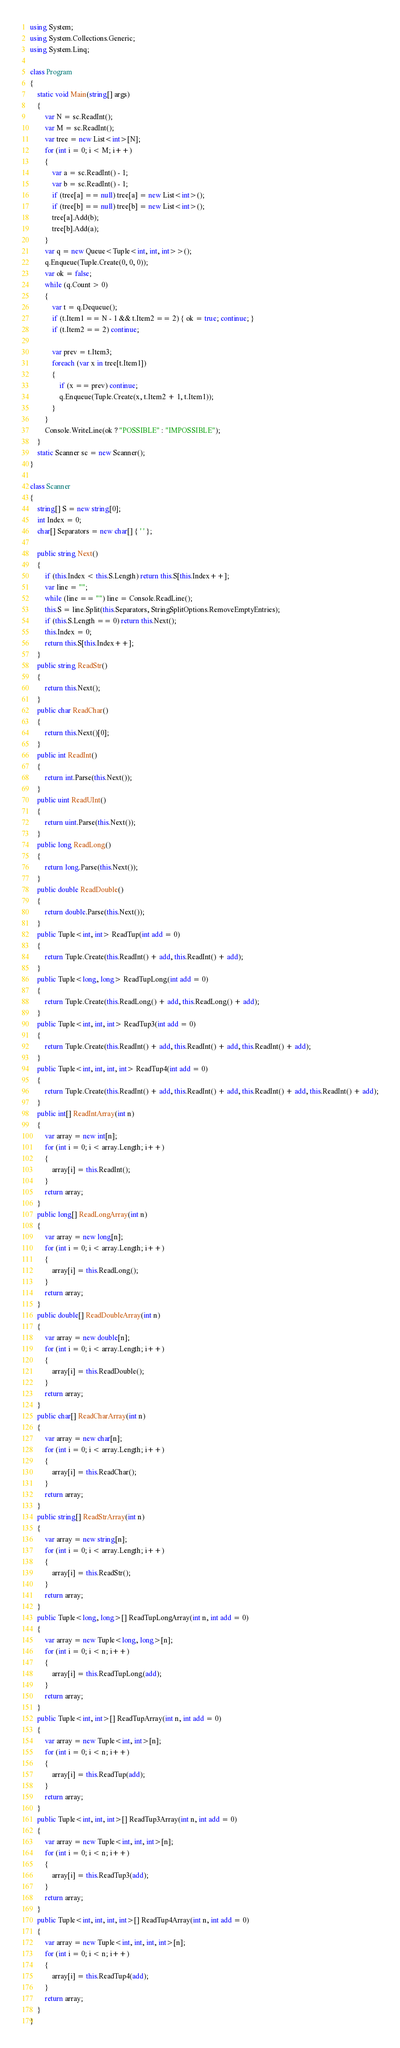<code> <loc_0><loc_0><loc_500><loc_500><_C#_>using System;
using System.Collections.Generic;
using System.Linq;

class Program
{
    static void Main(string[] args)
    {
        var N = sc.ReadInt();
        var M = sc.ReadInt();
        var tree = new List<int>[N];
        for (int i = 0; i < M; i++)
        {
            var a = sc.ReadInt() - 1;
            var b = sc.ReadInt() - 1;
            if (tree[a] == null) tree[a] = new List<int>();
            if (tree[b] == null) tree[b] = new List<int>();
            tree[a].Add(b);
            tree[b].Add(a);
        }
        var q = new Queue<Tuple<int, int, int>>();
        q.Enqueue(Tuple.Create(0, 0, 0));
        var ok = false;
        while (q.Count > 0)
        {
            var t = q.Dequeue();
            if (t.Item1 == N - 1 && t.Item2 == 2) { ok = true; continue; }
            if (t.Item2 == 2) continue;

            var prev = t.Item3;
            foreach (var x in tree[t.Item1])
            {
                if (x == prev) continue;
                q.Enqueue(Tuple.Create(x, t.Item2 + 1, t.Item1));
            }
        }
        Console.WriteLine(ok ? "POSSIBLE" : "IMPOSSIBLE");
    }
    static Scanner sc = new Scanner();
}

class Scanner
{
    string[] S = new string[0];
    int Index = 0;
    char[] Separators = new char[] { ' ' };

    public string Next()
    {
        if (this.Index < this.S.Length) return this.S[this.Index++];
        var line = "";
        while (line == "") line = Console.ReadLine();
        this.S = line.Split(this.Separators, StringSplitOptions.RemoveEmptyEntries);
        if (this.S.Length == 0) return this.Next();
        this.Index = 0;
        return this.S[this.Index++];
    }
    public string ReadStr()
    {
        return this.Next();
    }
    public char ReadChar()
    {
        return this.Next()[0];
    }
    public int ReadInt()
    {
        return int.Parse(this.Next());
    }
    public uint ReadUInt()
    {
        return uint.Parse(this.Next());
    }
    public long ReadLong()
    {
        return long.Parse(this.Next());
    }
    public double ReadDouble()
    {
        return double.Parse(this.Next());
    }
    public Tuple<int, int> ReadTup(int add = 0)
    {
        return Tuple.Create(this.ReadInt() + add, this.ReadInt() + add);
    }
    public Tuple<long, long> ReadTupLong(int add = 0)
    {
        return Tuple.Create(this.ReadLong() + add, this.ReadLong() + add);
    }
    public Tuple<int, int, int> ReadTup3(int add = 0)
    {
        return Tuple.Create(this.ReadInt() + add, this.ReadInt() + add, this.ReadInt() + add);
    }
    public Tuple<int, int, int, int> ReadTup4(int add = 0)
    {
        return Tuple.Create(this.ReadInt() + add, this.ReadInt() + add, this.ReadInt() + add, this.ReadInt() + add);
    }
    public int[] ReadIntArray(int n)
    {
        var array = new int[n];
        for (int i = 0; i < array.Length; i++)
        {
            array[i] = this.ReadInt();
        }
        return array;
    }
    public long[] ReadLongArray(int n)
    {
        var array = new long[n];
        for (int i = 0; i < array.Length; i++)
        {
            array[i] = this.ReadLong();
        }
        return array;
    }
    public double[] ReadDoubleArray(int n)
    {
        var array = new double[n];
        for (int i = 0; i < array.Length; i++)
        {
            array[i] = this.ReadDouble();
        }
        return array;
    }
    public char[] ReadCharArray(int n)
    {
        var array = new char[n];
        for (int i = 0; i < array.Length; i++)
        {
            array[i] = this.ReadChar();
        }
        return array;
    }
    public string[] ReadStrArray(int n)
    {
        var array = new string[n];
        for (int i = 0; i < array.Length; i++)
        {
            array[i] = this.ReadStr();
        }
        return array;
    }
    public Tuple<long, long>[] ReadTupLongArray(int n, int add = 0)
    {
        var array = new Tuple<long, long>[n];
        for (int i = 0; i < n; i++)
        {
            array[i] = this.ReadTupLong(add);
        }
        return array;
    }
    public Tuple<int, int>[] ReadTupArray(int n, int add = 0)
    {
        var array = new Tuple<int, int>[n];
        for (int i = 0; i < n; i++)
        {
            array[i] = this.ReadTup(add);
        }
        return array;
    }
    public Tuple<int, int, int>[] ReadTup3Array(int n, int add = 0)
    {
        var array = new Tuple<int, int, int>[n];
        for (int i = 0; i < n; i++)
        {
            array[i] = this.ReadTup3(add);
        }
        return array;
    }
    public Tuple<int, int, int, int>[] ReadTup4Array(int n, int add = 0)
    {
        var array = new Tuple<int, int, int, int>[n];
        for (int i = 0; i < n; i++)
        {
            array[i] = this.ReadTup4(add);
        }
        return array;
    }
}
</code> 